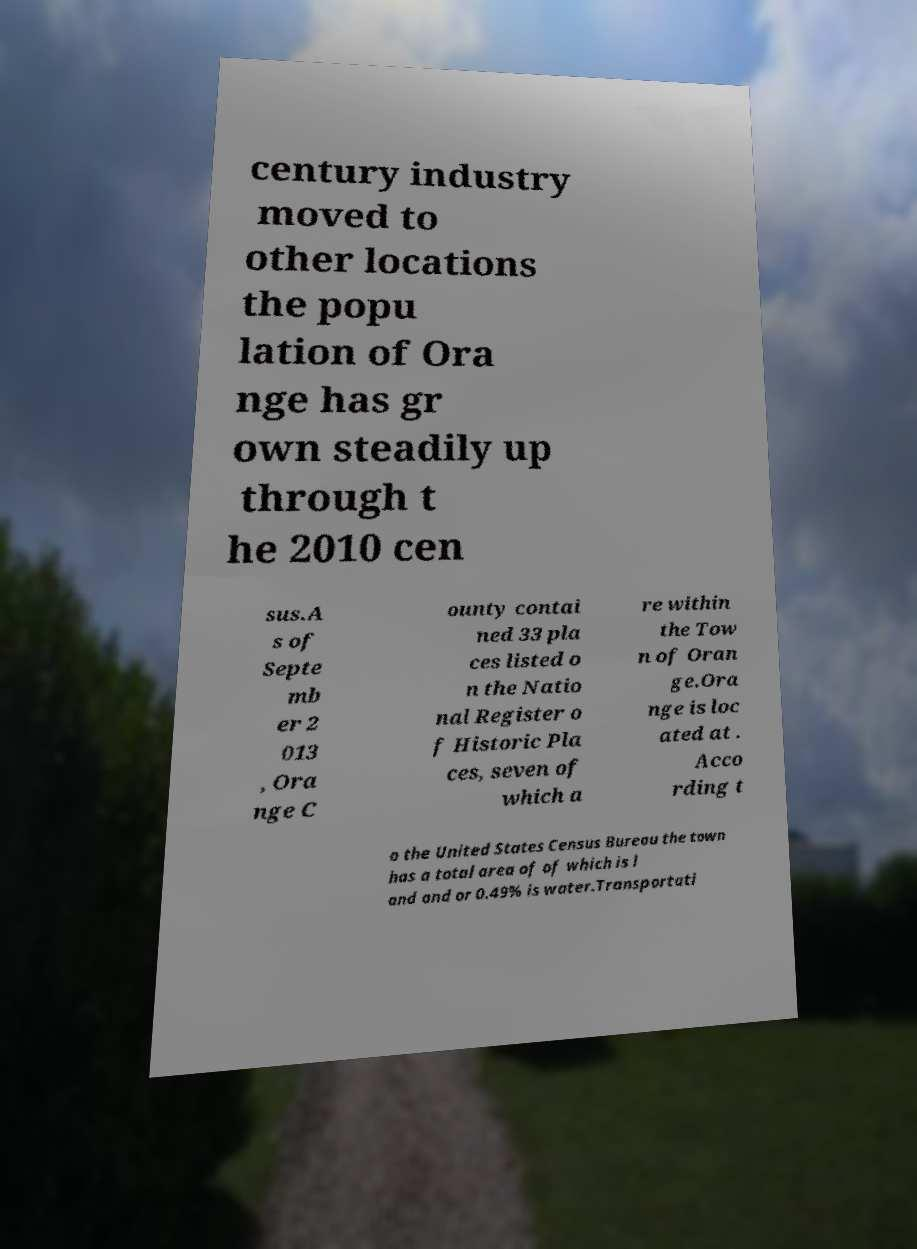Could you extract and type out the text from this image? century industry moved to other locations the popu lation of Ora nge has gr own steadily up through t he 2010 cen sus.A s of Septe mb er 2 013 , Ora nge C ounty contai ned 33 pla ces listed o n the Natio nal Register o f Historic Pla ces, seven of which a re within the Tow n of Oran ge.Ora nge is loc ated at . Acco rding t o the United States Census Bureau the town has a total area of of which is l and and or 0.49% is water.Transportati 